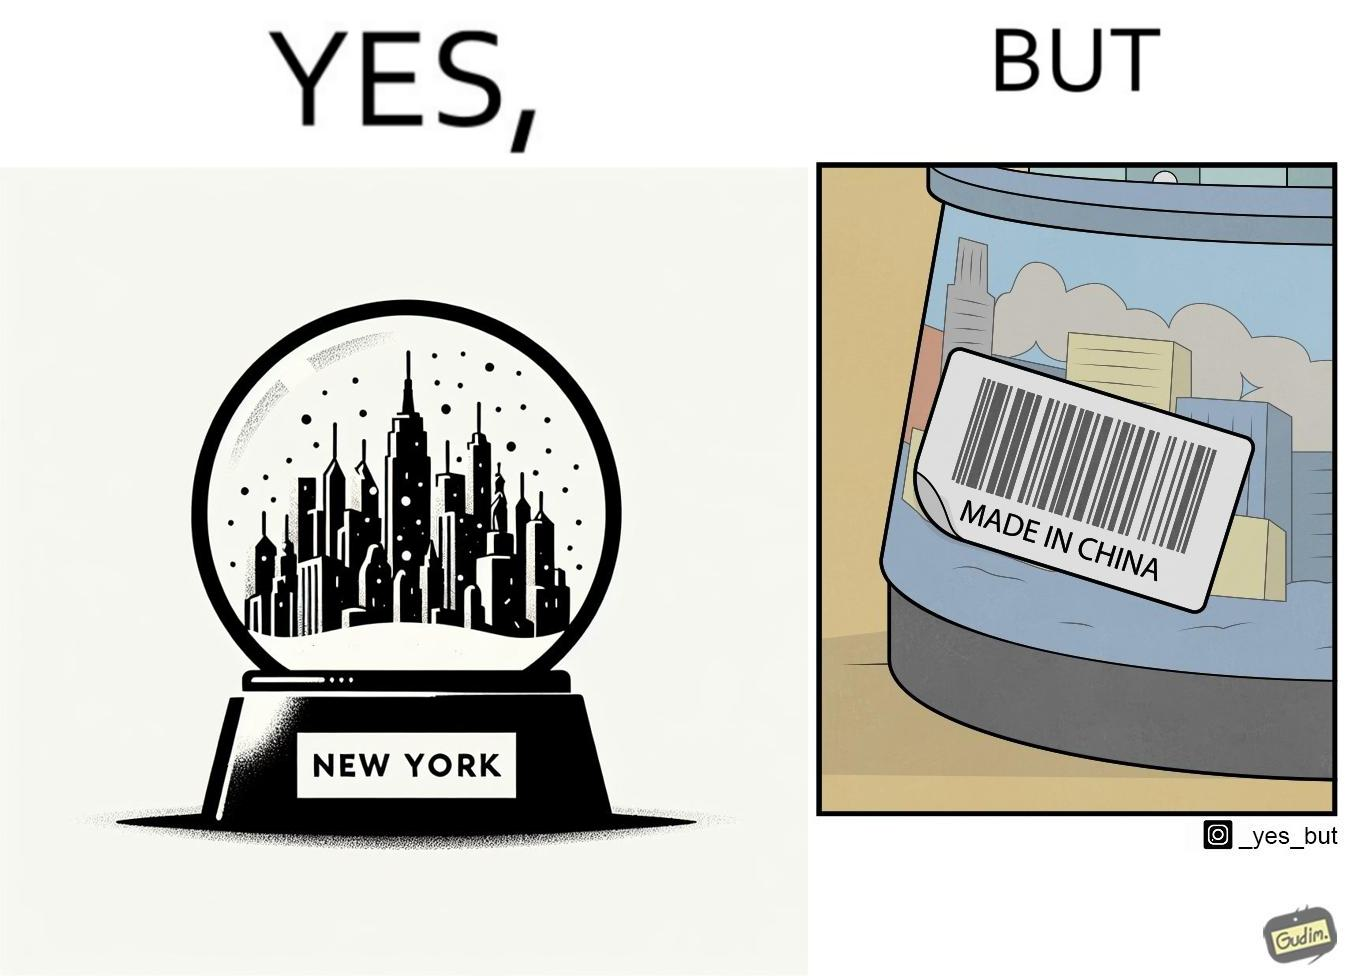What is the satirical meaning behind this image? The image is ironic because the snowglobe says 'New York' while it is made in China 